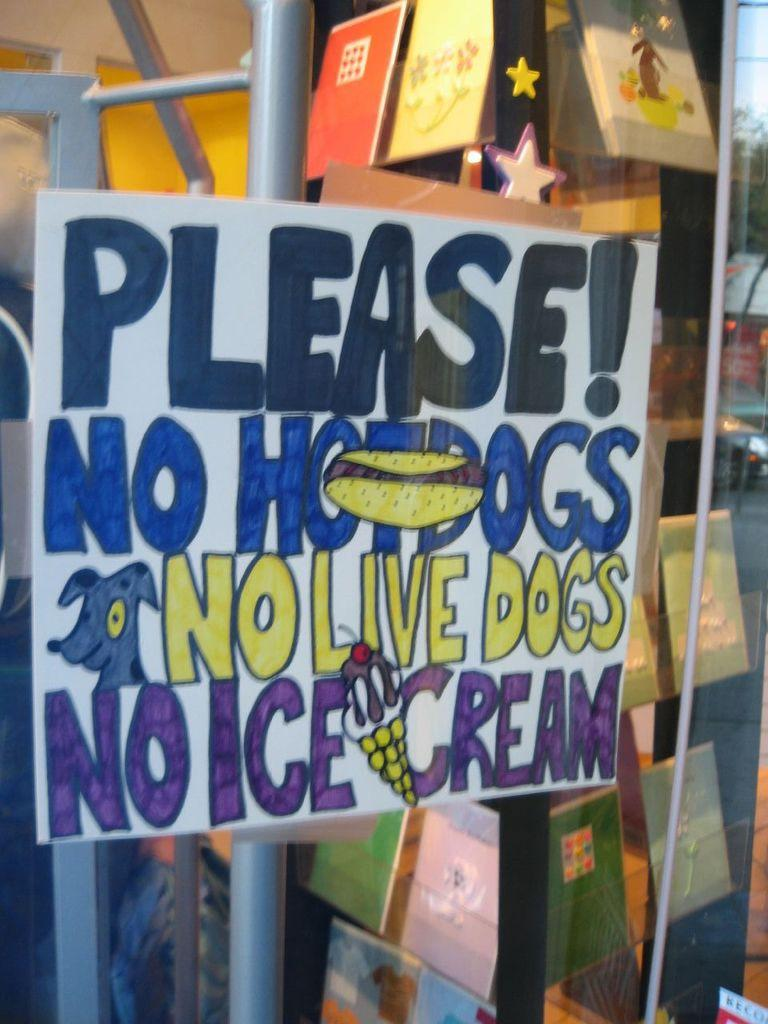<image>
Provide a brief description of the given image. A poster in a window front of a store saying Please! No Hotdogs No Live Dogs No Ice cream. 